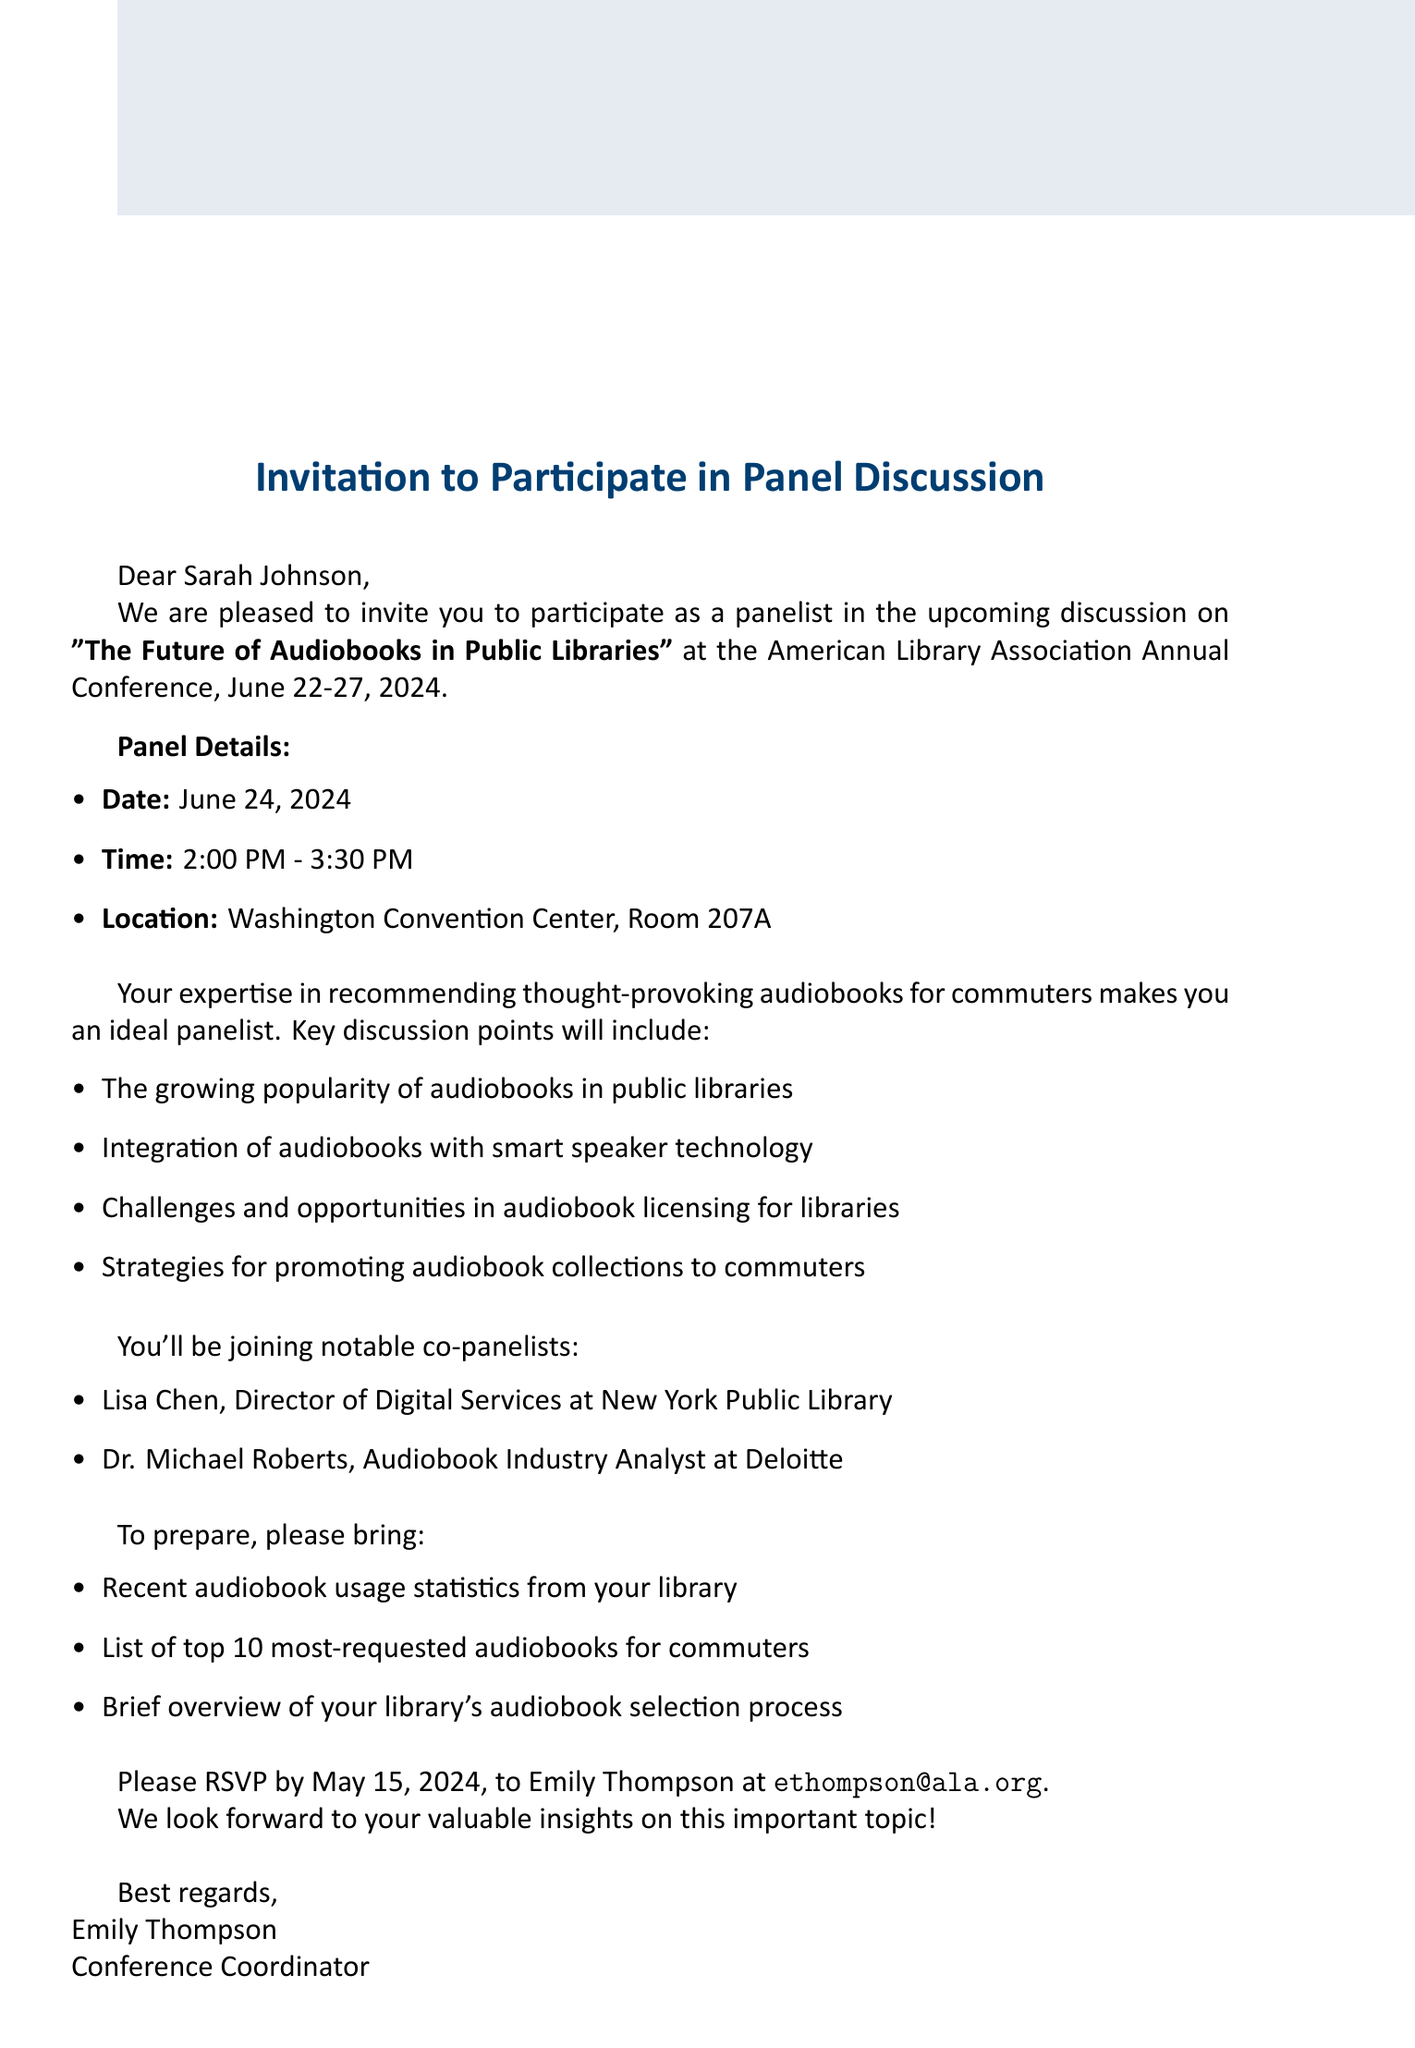What is the title of the panel discussion? The title of the panel discussion is explicitly mentioned in the document as "The Future of Audiobooks in Public Libraries."
Answer: The Future of Audiobooks in Public Libraries Who is the recipient of the invitation? The email specifies that the invitation is addressed to Sarah Johnson, who is the Head Librarian.
Answer: Sarah Johnson What is the date of the panel discussion? The date of the panel discussion is clearly stated in the document as June 24, 2024.
Answer: June 24, 2024 What are the key discussion points? The document lists several key discussion points regarding audiobooks, such as their growing popularity in public libraries and integration with smart speaker technology.
Answer: The growing popularity of audiobooks in public libraries, integration of audiobooks with smart speaker technology, challenges and opportunities in audiobook licensing for libraries, strategies for promoting audiobook collections to commuters When is the RSVP deadline? The document indicates the RSVP deadline for the panel discussion participation is May 15, 2024.
Answer: May 15, 2024 Who should be contacted for more information? The contact person is specifically mentioned as Emily Thompson, along with her email address for further inquiries.
Answer: Emily Thompson What location is specified for the panel? The location for the panel discussion is provided as Washington Convention Center, Room 207A.
Answer: Washington Convention Center, Room 207A 